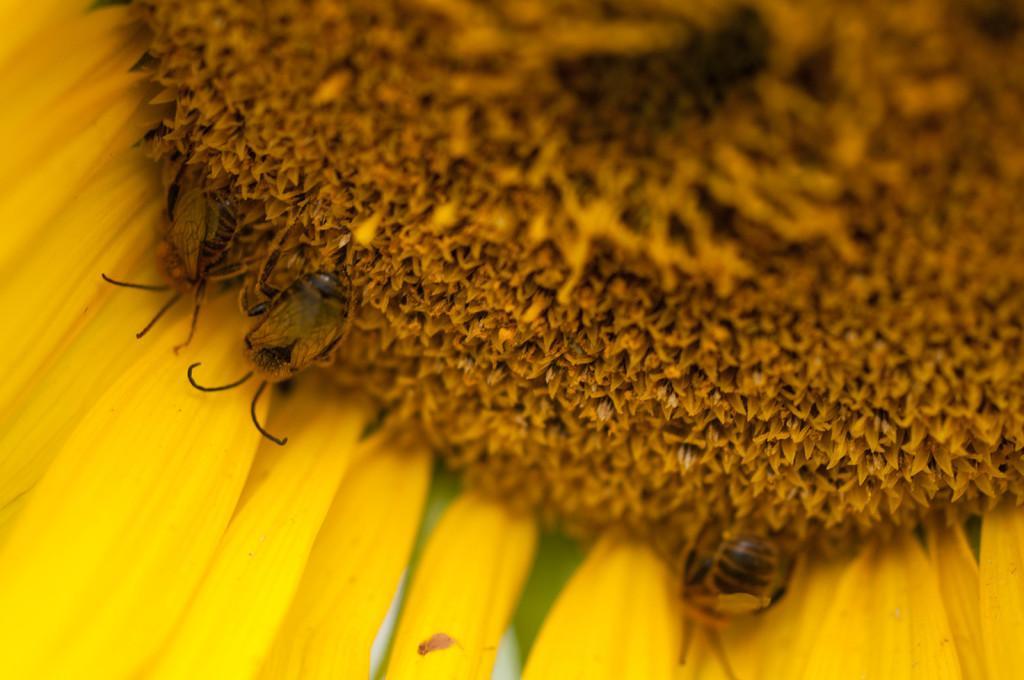Please provide a concise description of this image. In this image there are bees on the sunflower. 